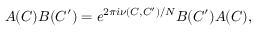<formula> <loc_0><loc_0><loc_500><loc_500>A ( C ) B ( C ^ { \prime } ) = e ^ { 2 \pi i \nu ( C , C ^ { \prime } ) / N } B ( C ^ { \prime } ) A ( C ) ,</formula> 